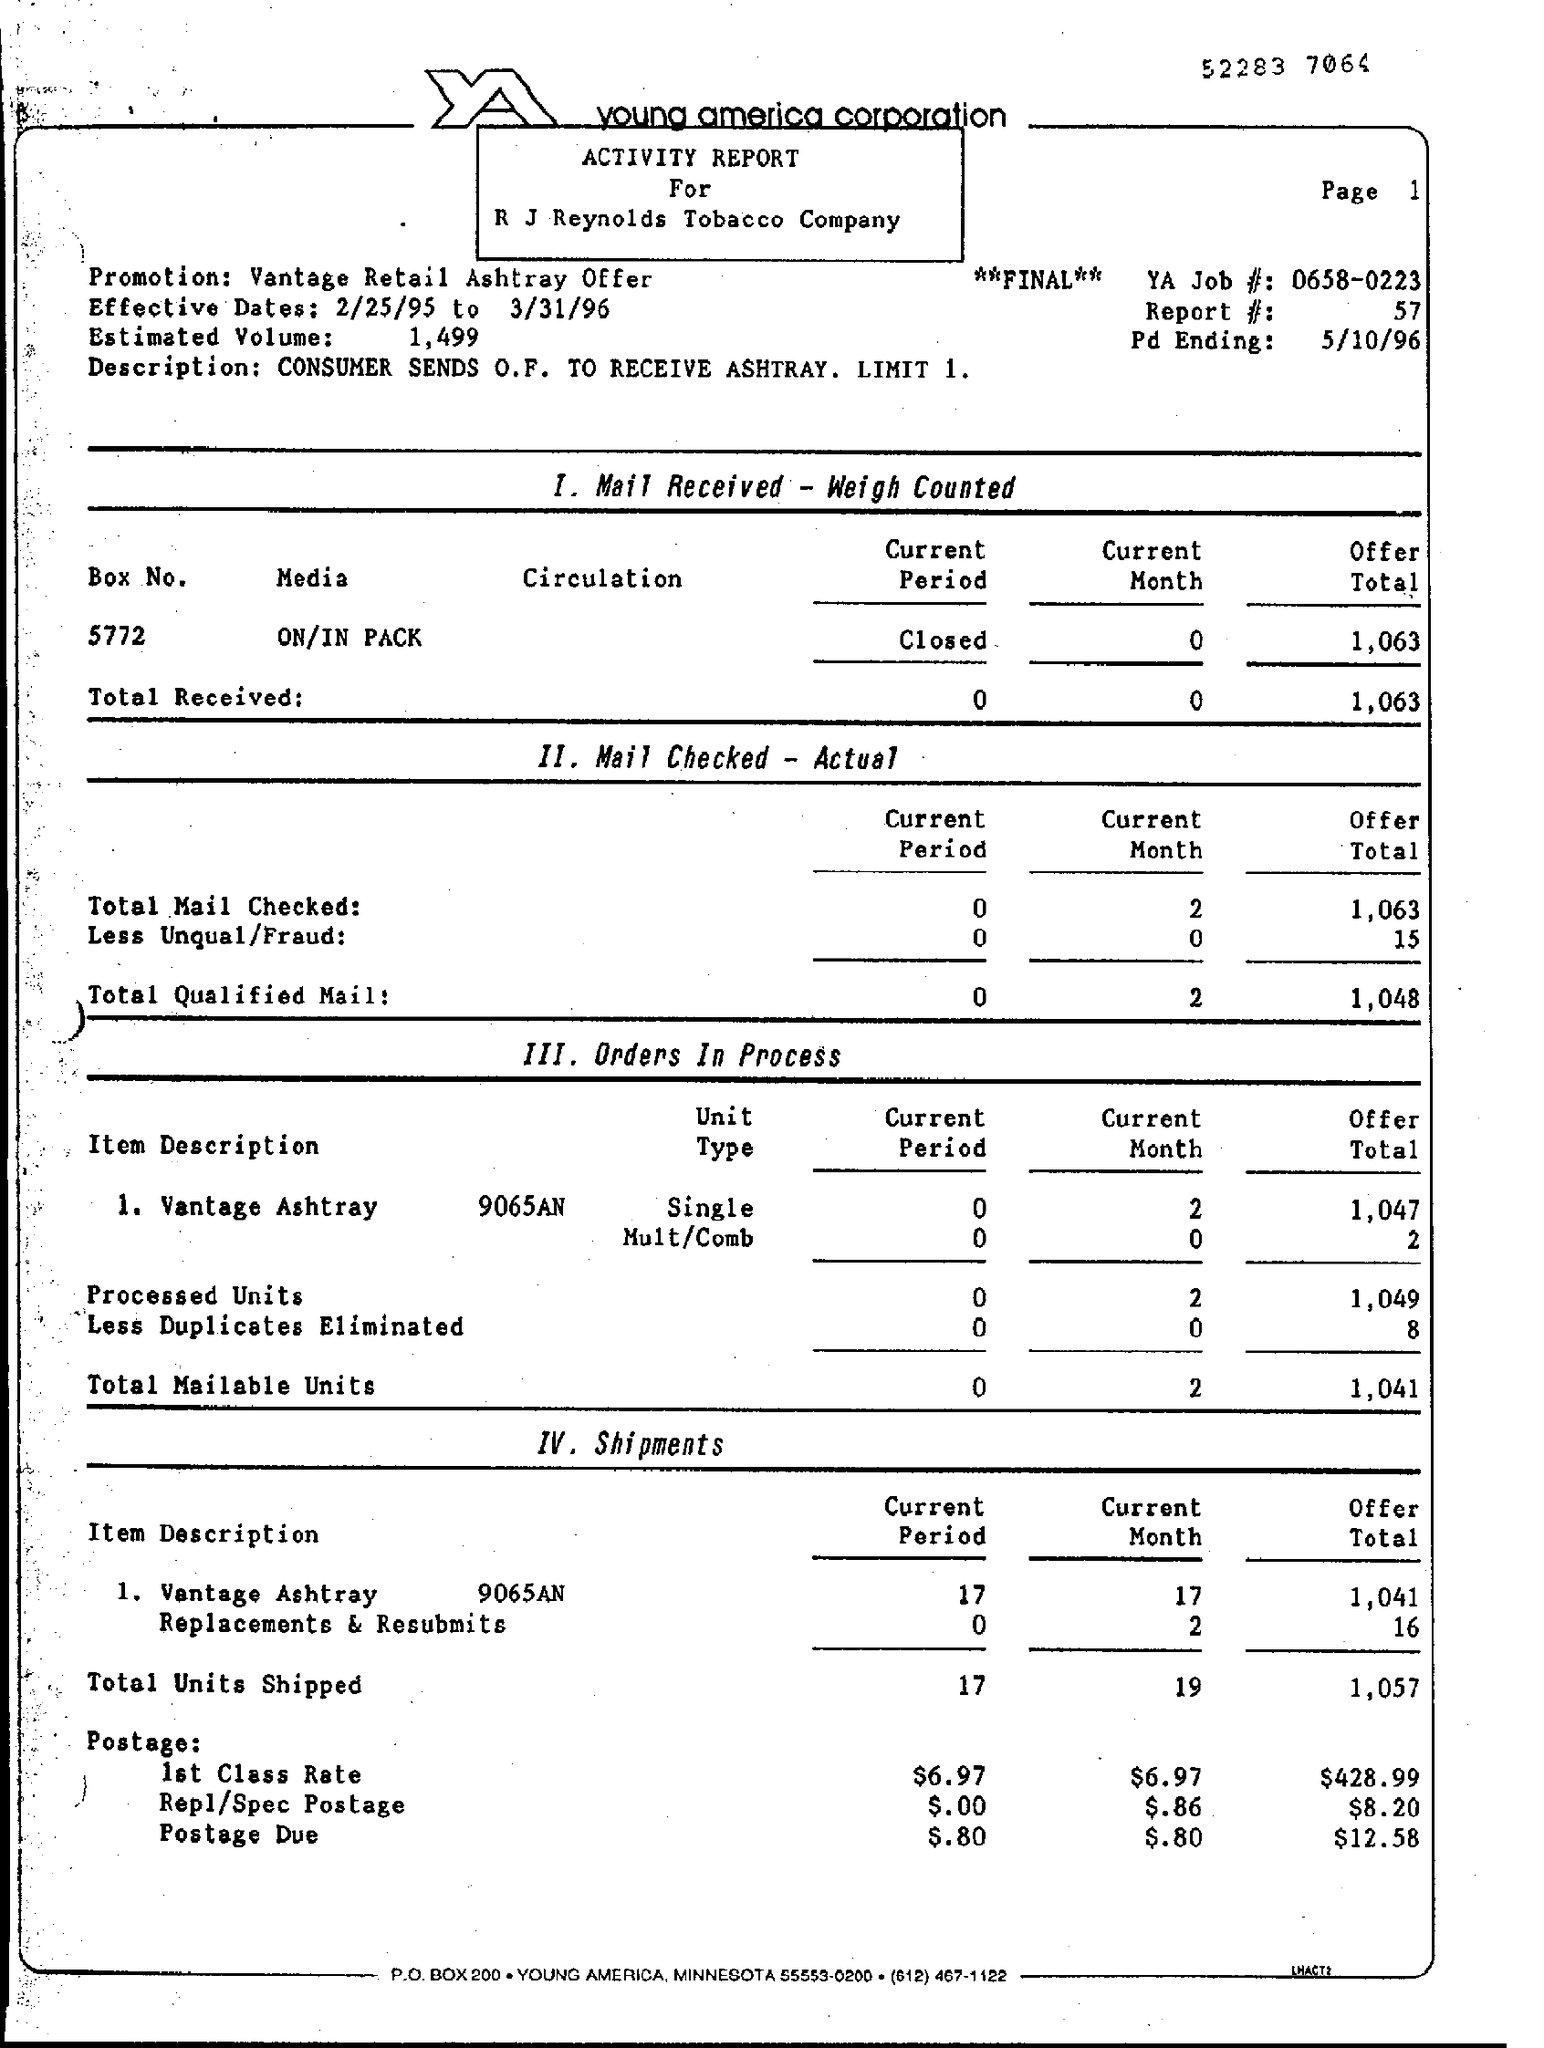Which firm is mentioned at the top of the page?
Your response must be concise. Young america corporation. What is the document title?
Your answer should be compact. ACTIVITY REPORT For R J Reynolds Tobacco Company. What are the effective dates?
Make the answer very short. 2/25/95 to 3/31/96. What is the description?
Your answer should be compact. CONSUMER SENDS O.F. TO RECEIVE ASHTRAY. LIMIT 1. 